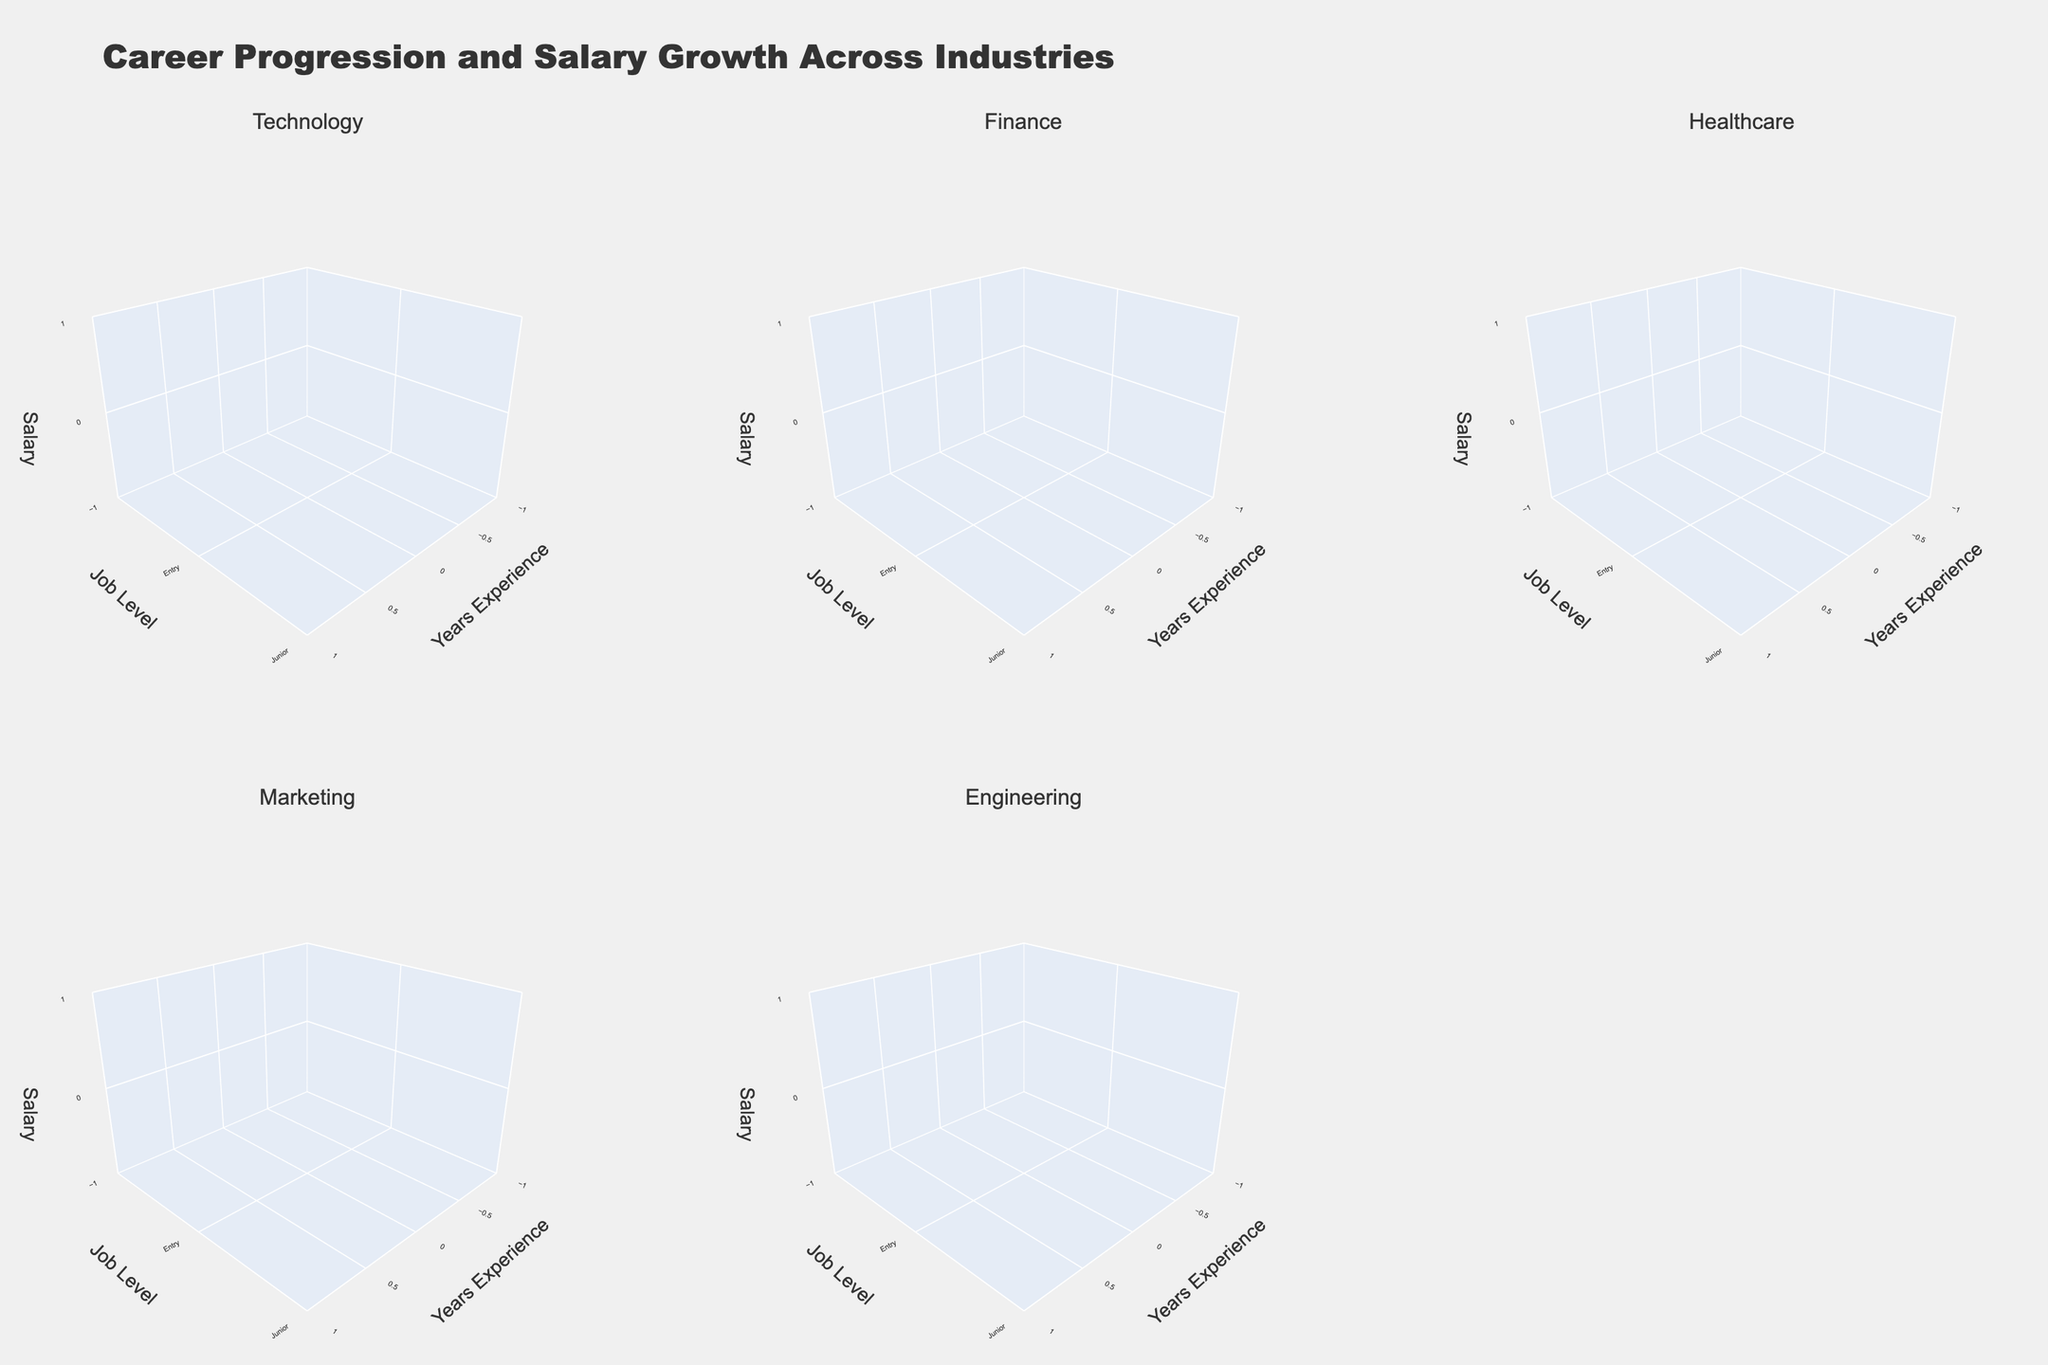What is the overall title of the figure? The title is prominently displayed at the top of the figure. It reads: "Career Progression and Salary Growth Across Industries".
Answer: Career Progression and Salary Growth Across Industries What are the titles of the subplots for each industry? The subplot titles are visible at the top of each 3D plot. They are: "Technology", "Finance", "Healthcare", "Marketing", "Engineering".
Answer: Technology, Finance, Healthcare, Marketing, Engineering Which industry shows the highest salary for mid-level professionals? In the "Finance" subplot, the 3D surface plot shows the highest elevation for mid-level job levels compared to other industries.
Answer: Finance What are the axis labels used in the plots? Each subplot has axis labels: the x-axis is labeled 'Years Experience', the y-axis is labeled 'Job Level', and the z-axis is labeled 'Salary'.
Answer: Years Experience, Job Level, Salary How does the salary growth rate for entry-level positions compare across industries? By observing the lowest areas on the z-axis (Salary) of each subplot, we can see the relative starting salary levels. Higher elevations indicate higher starting salaries, showing Finance has the highest starting salaries, followed by Technology, Engineering, Healthcare, and Marketing.
Answer: Finance > Technology > Engineering > Healthcare > Marketing In which industry is the salary increase for senior positions more gradual? The plots show a relatively flat slope for senior levels in Technology and Healthcare, indicating more gradual salary increases, compared to steeper slopes in other industries.
Answer: Technology and Healthcare What's the average salary for junior-level professionals in the Healthcare industry? The subplot for Healthcare shows the elevation on the 3D surface for junior levels. By visually estimating, junior healthcare roles have salaries around 65,000.
Answer: Around 65,000 Which industry has the fastest salary growth within the first three years? By examining the initial steepness of the z-axis (Salary) against the x-axis (Years Experience), Finance and Engineering show the steepest slopes, indicating rapid salary growth.
Answer: Finance and Engineering 